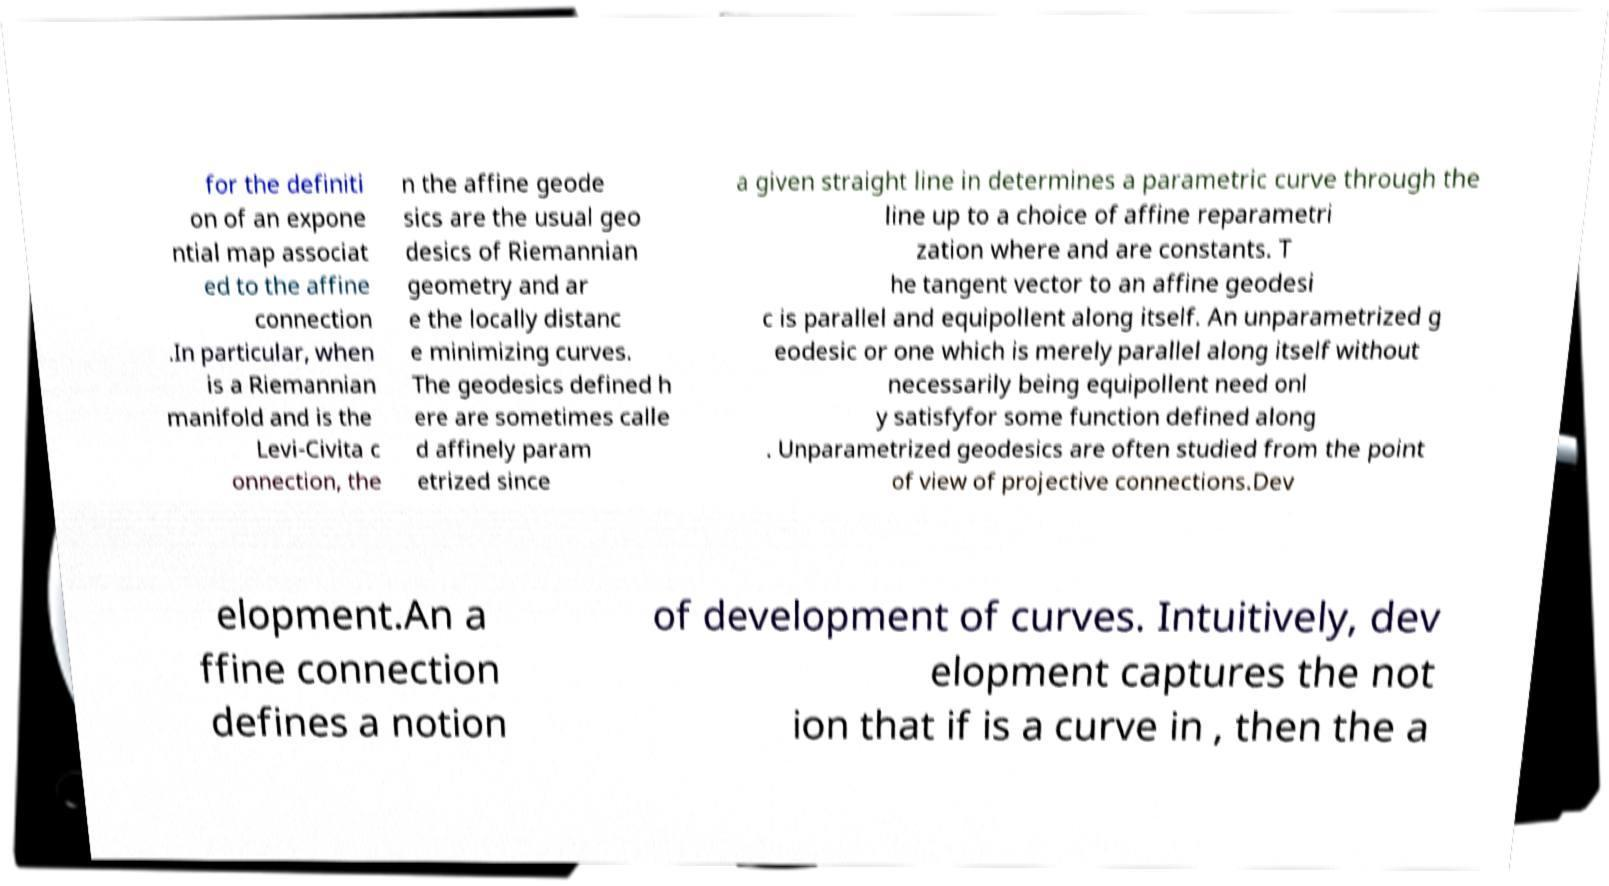What messages or text are displayed in this image? I need them in a readable, typed format. for the definiti on of an expone ntial map associat ed to the affine connection .In particular, when is a Riemannian manifold and is the Levi-Civita c onnection, the n the affine geode sics are the usual geo desics of Riemannian geometry and ar e the locally distanc e minimizing curves. The geodesics defined h ere are sometimes calle d affinely param etrized since a given straight line in determines a parametric curve through the line up to a choice of affine reparametri zation where and are constants. T he tangent vector to an affine geodesi c is parallel and equipollent along itself. An unparametrized g eodesic or one which is merely parallel along itself without necessarily being equipollent need onl y satisfyfor some function defined along . Unparametrized geodesics are often studied from the point of view of projective connections.Dev elopment.An a ffine connection defines a notion of development of curves. Intuitively, dev elopment captures the not ion that if is a curve in , then the a 